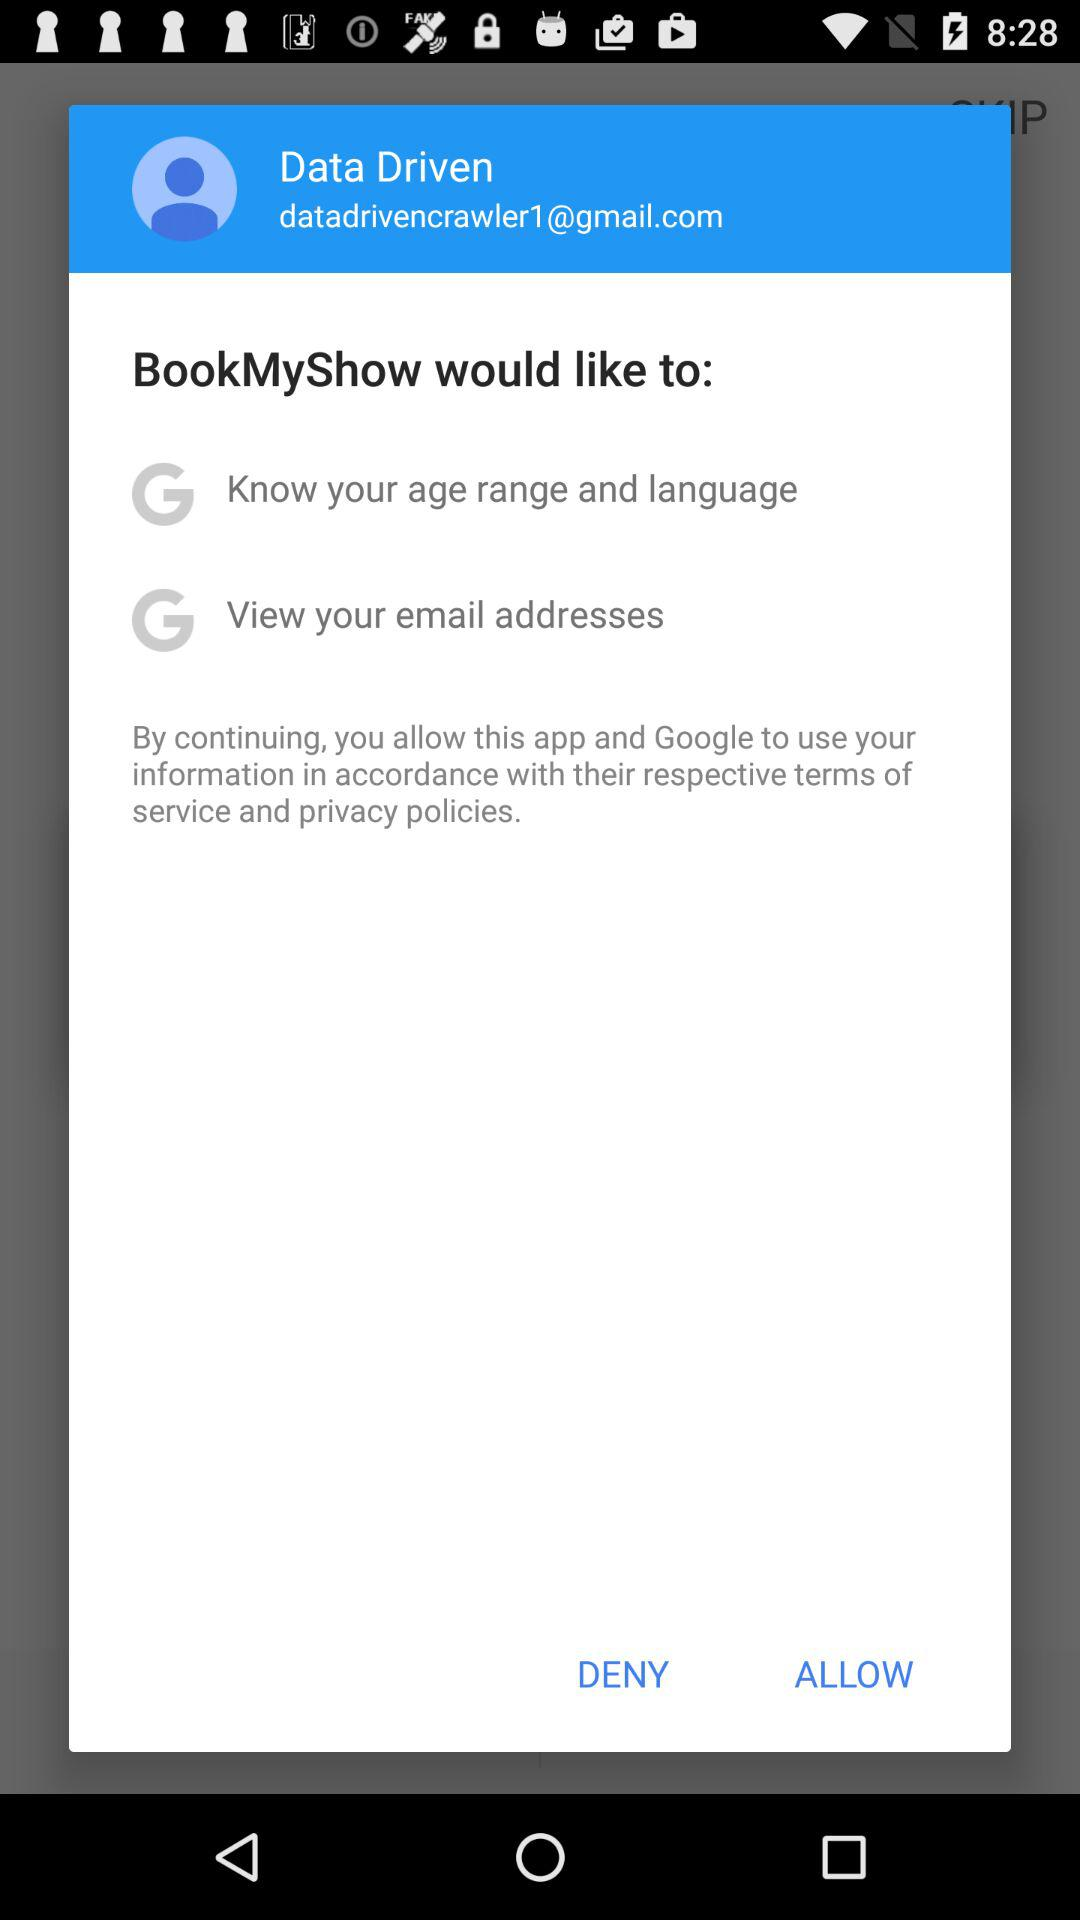How many data items are requested by BookMyShow?
Answer the question using a single word or phrase. 2 